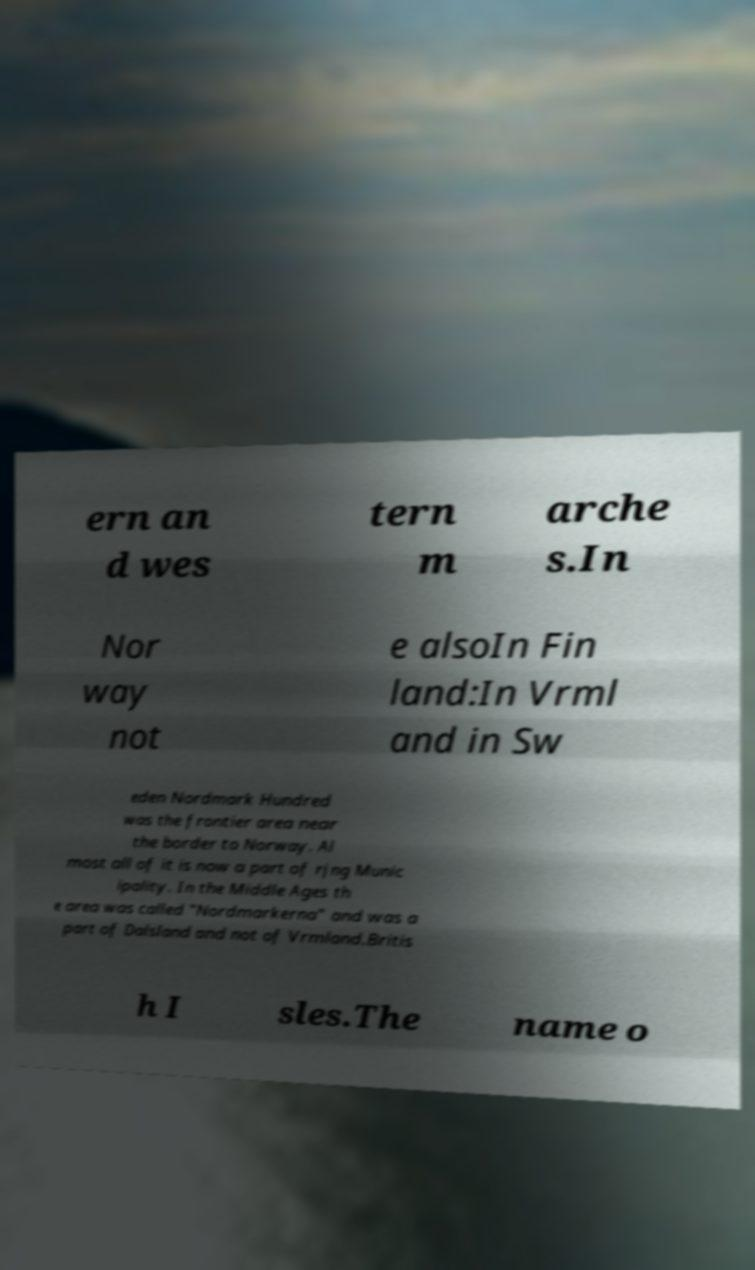Please identify and transcribe the text found in this image. ern an d wes tern m arche s.In Nor way not e alsoIn Fin land:In Vrml and in Sw eden Nordmark Hundred was the frontier area near the border to Norway. Al most all of it is now a part of rjng Munic ipality. In the Middle Ages th e area was called "Nordmarkerna" and was a part of Dalsland and not of Vrmland.Britis h I sles.The name o 